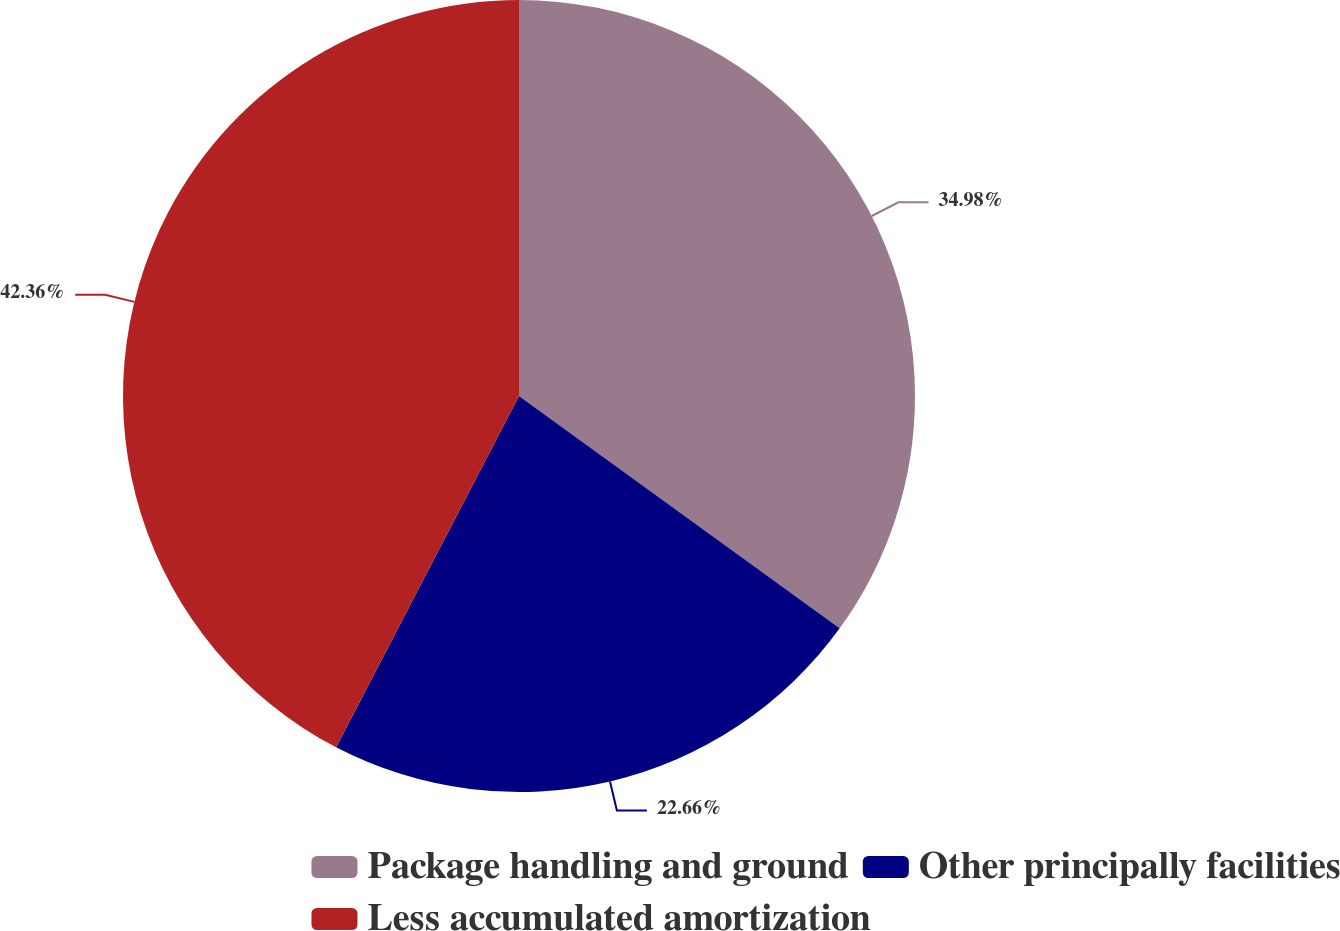<chart> <loc_0><loc_0><loc_500><loc_500><pie_chart><fcel>Package handling and ground<fcel>Other principally facilities<fcel>Less accumulated amortization<nl><fcel>34.98%<fcel>22.66%<fcel>42.36%<nl></chart> 